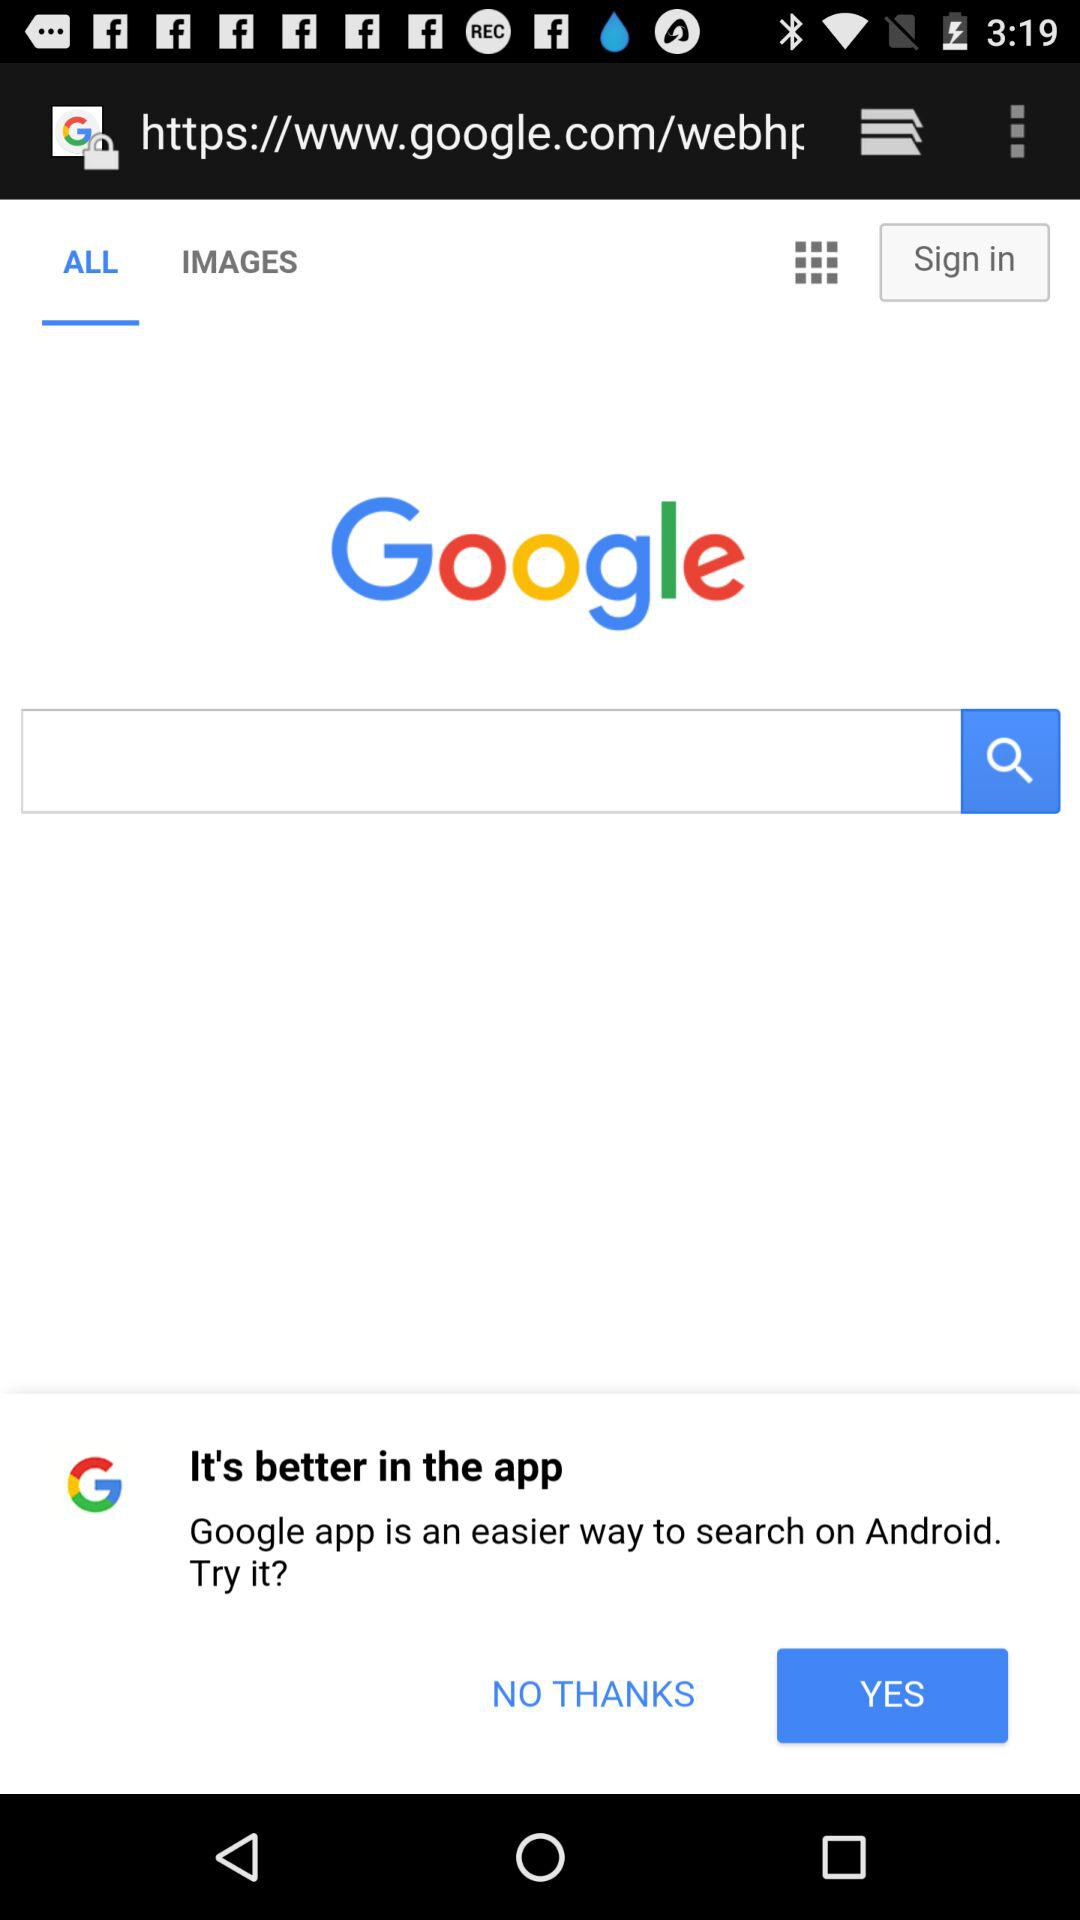Which tab is selected? The selected tab is "ALL". 